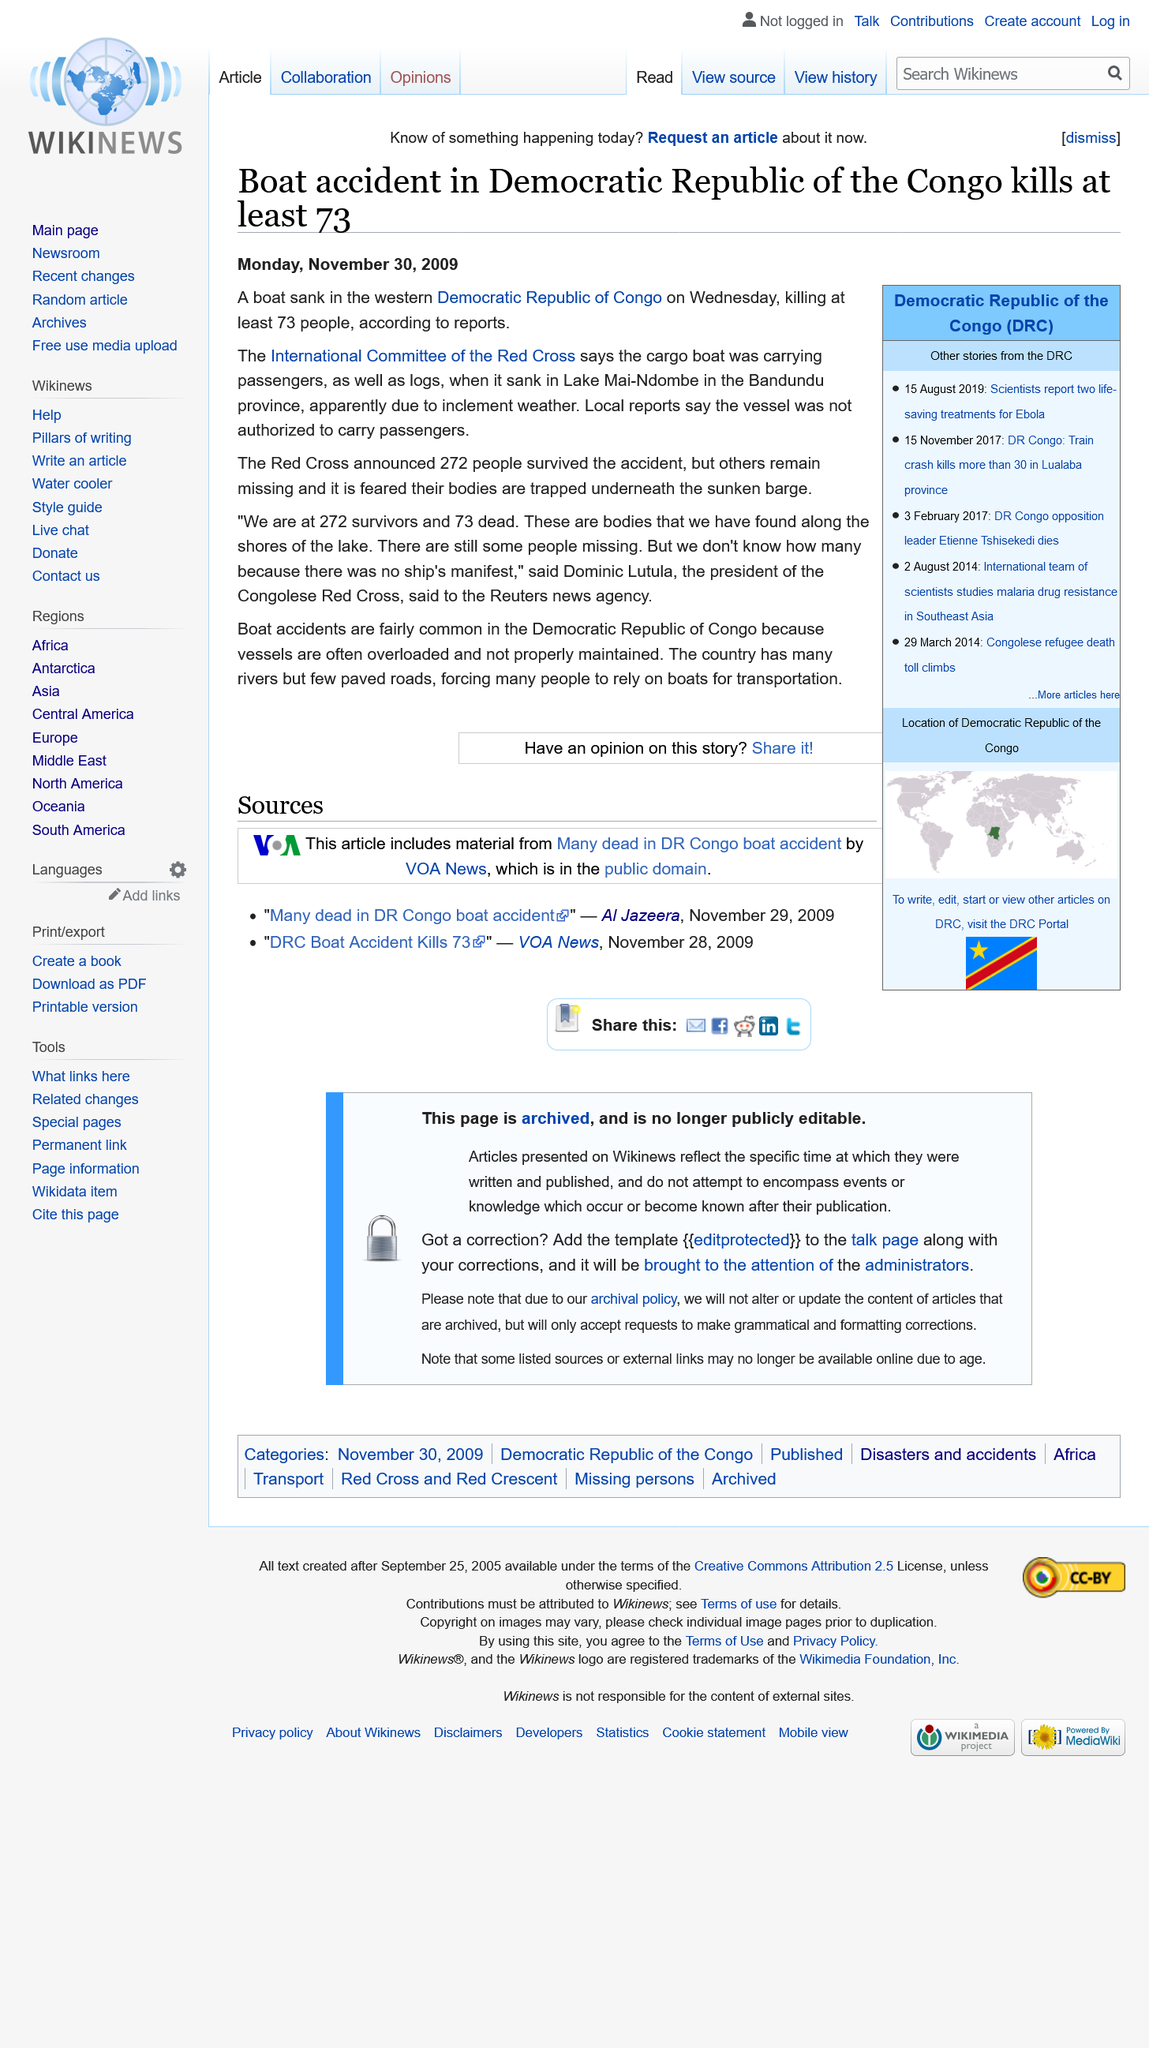Mention a couple of crucial points in this snapshot. Boat accidents are a fairly common occurrence in the Democratic Republic of Congo. The Red Cross announced that 272 individuals survived the recent accident. The article on the boat that sank was published on Monday, November 30, 2009. 